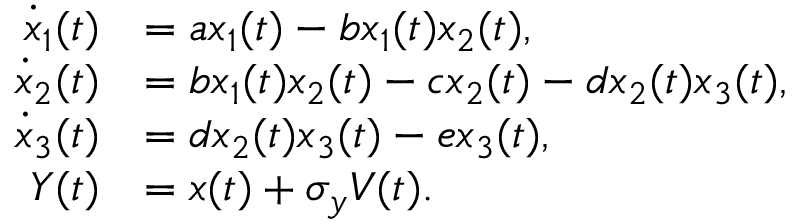Convert formula to latex. <formula><loc_0><loc_0><loc_500><loc_500>\begin{array} { r l } { \dot { x } _ { 1 } ( t ) } & { = a x _ { 1 } ( t ) - b x _ { 1 } ( t ) x _ { 2 } ( t ) , } \\ { \dot { x } _ { 2 } ( t ) } & { = b x _ { 1 } ( t ) x _ { 2 } ( t ) - c x _ { 2 } ( t ) - d x _ { 2 } ( t ) x _ { 3 } ( t ) , } \\ { \dot { x } _ { 3 } ( t ) } & { = d x _ { 2 } ( t ) x _ { 3 } ( t ) - e x _ { 3 } ( t ) , } \\ { Y ( t ) } & { = x ( t ) + \sigma _ { y } V ( t ) . } \end{array}</formula> 